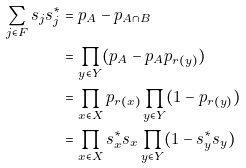Convert formula to latex. <formula><loc_0><loc_0><loc_500><loc_500>\sum _ { j \in F } s _ { j } s _ { j } ^ { * } & = p _ { A } - p _ { A \cap B } \\ & = \prod _ { y \in Y } ( p _ { A } - p _ { A } p _ { r ( y ) } ) \\ & = \prod _ { x \in X } p _ { r ( x ) } \prod _ { y \in Y } ( 1 - p _ { r ( y ) } ) \\ & = \prod _ { x \in X } s _ { x } ^ { * } s _ { x } \prod _ { y \in Y } ( 1 - s _ { y } ^ { * } s _ { y } )</formula> 